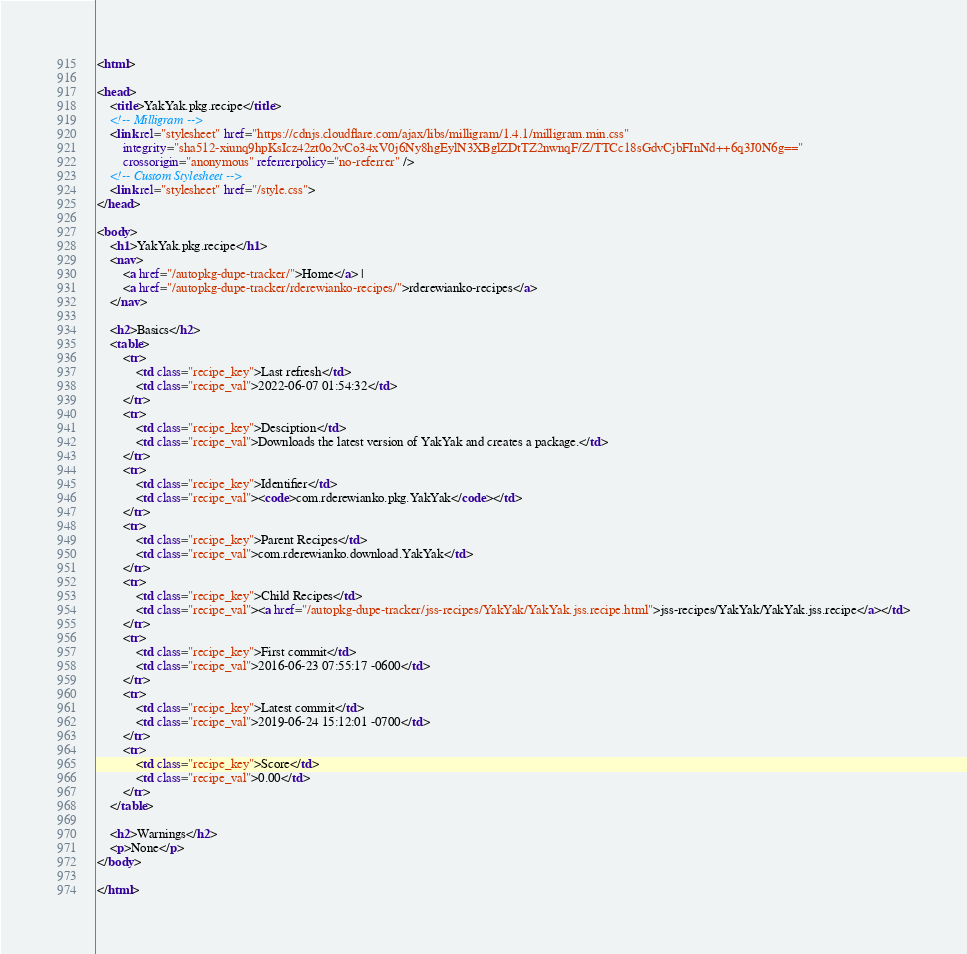<code> <loc_0><loc_0><loc_500><loc_500><_HTML_><html>

<head>
    <title>YakYak.pkg.recipe</title>
    <!-- Milligram -->
    <link rel="stylesheet" href="https://cdnjs.cloudflare.com/ajax/libs/milligram/1.4.1/milligram.min.css"
        integrity="sha512-xiunq9hpKsIcz42zt0o2vCo34xV0j6Ny8hgEylN3XBglZDtTZ2nwnqF/Z/TTCc18sGdvCjbFInNd++6q3J0N6g=="
        crossorigin="anonymous" referrerpolicy="no-referrer" />
    <!-- Custom Stylesheet -->
    <link rel="stylesheet" href="/style.css">
</head>

<body>
    <h1>YakYak.pkg.recipe</h1>
    <nav>
        <a href="/autopkg-dupe-tracker/">Home</a> |
        <a href="/autopkg-dupe-tracker/rderewianko-recipes/">rderewianko-recipes</a>
    </nav>

    <h2>Basics</h2>
    <table>
        <tr>
            <td class="recipe_key">Last refresh</td>
            <td class="recipe_val">2022-06-07 01:54:32</td>
        </tr>
        <tr>
            <td class="recipe_key">Desciption</td>
            <td class="recipe_val">Downloads the latest version of YakYak and creates a package.</td>
        </tr>
        <tr>
            <td class="recipe_key">Identifier</td>
            <td class="recipe_val"><code>com.rderewianko.pkg.YakYak</code></td>
        </tr>
        <tr>
            <td class="recipe_key">Parent Recipes</td>
            <td class="recipe_val">com.rderewianko.download.YakYak</td>
        </tr>
        <tr>
            <td class="recipe_key">Child Recipes</td>
            <td class="recipe_val"><a href="/autopkg-dupe-tracker/jss-recipes/YakYak/YakYak.jss.recipe.html">jss-recipes/YakYak/YakYak.jss.recipe</a></td>
        </tr>
        <tr>
            <td class="recipe_key">First commit</td>
            <td class="recipe_val">2016-06-23 07:55:17 -0600</td>
        </tr>
        <tr>
            <td class="recipe_key">Latest commit</td>
            <td class="recipe_val">2019-06-24 15:12:01 -0700</td>
        </tr>
        <tr>
            <td class="recipe_key">Score</td>
            <td class="recipe_val">0.00</td>
        </tr>
    </table>

    <h2>Warnings</h2>
    <p>None</p>
</body>

</html>
</code> 